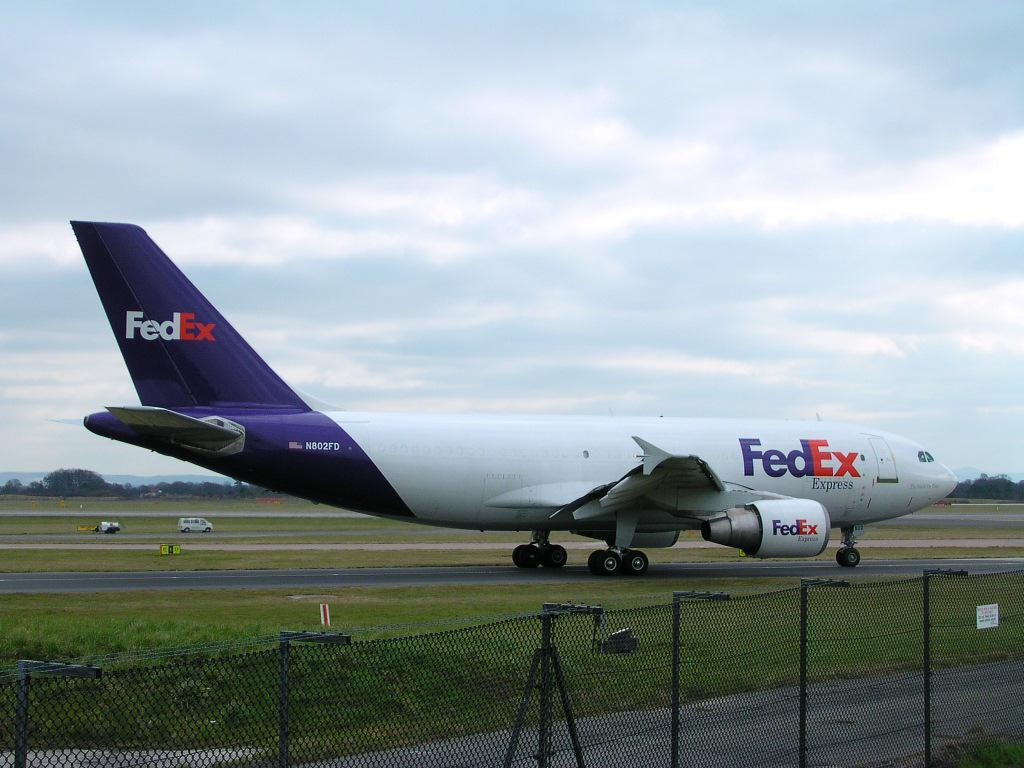<image>
Provide a brief description of the given image. A Fedex plane taxis on the runway near a fence. 